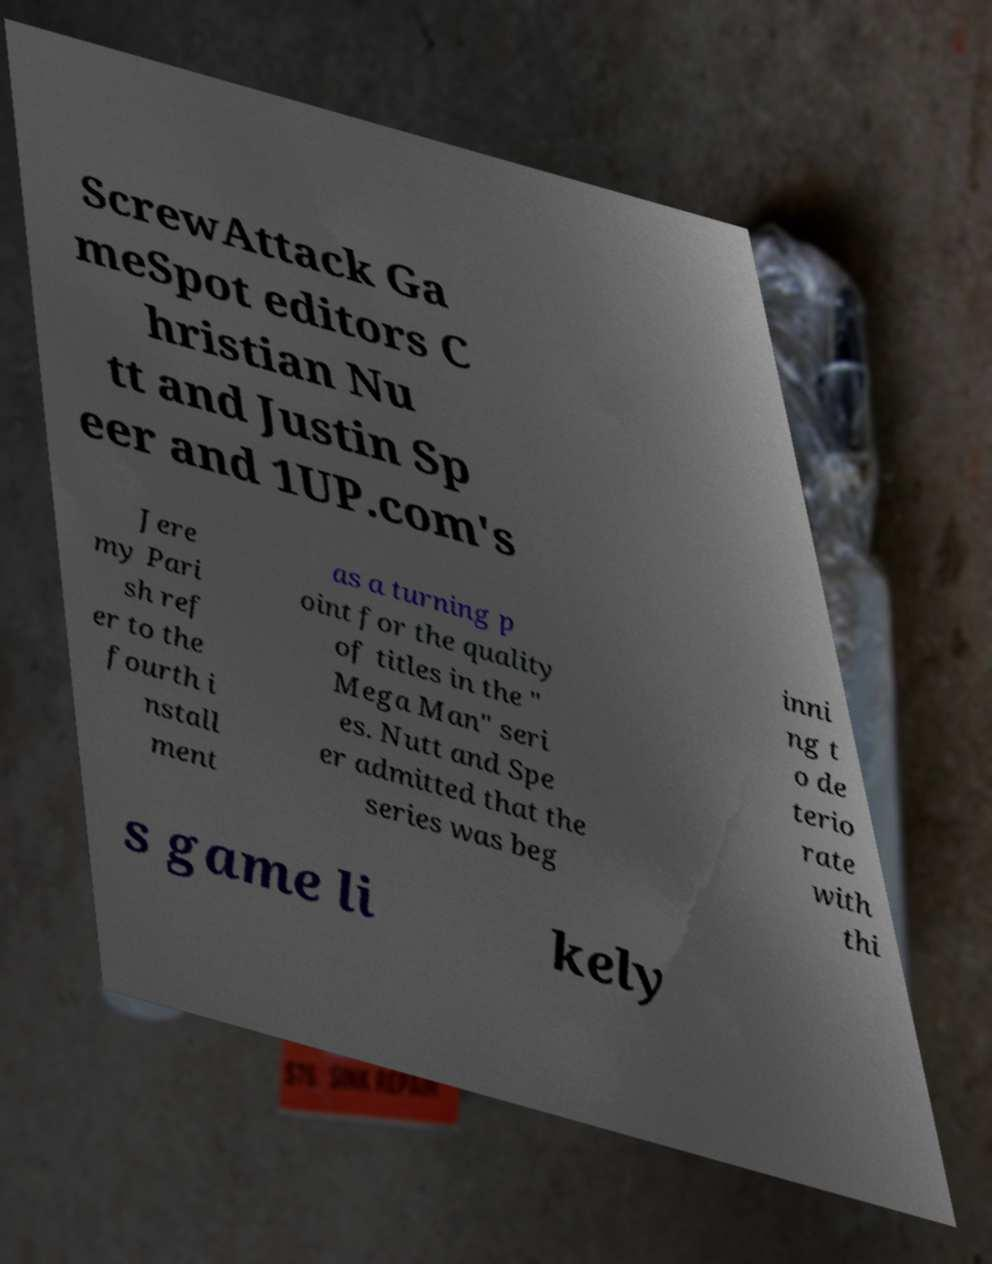There's text embedded in this image that I need extracted. Can you transcribe it verbatim? ScrewAttack Ga meSpot editors C hristian Nu tt and Justin Sp eer and 1UP.com's Jere my Pari sh ref er to the fourth i nstall ment as a turning p oint for the quality of titles in the " Mega Man" seri es. Nutt and Spe er admitted that the series was beg inni ng t o de terio rate with thi s game li kely 